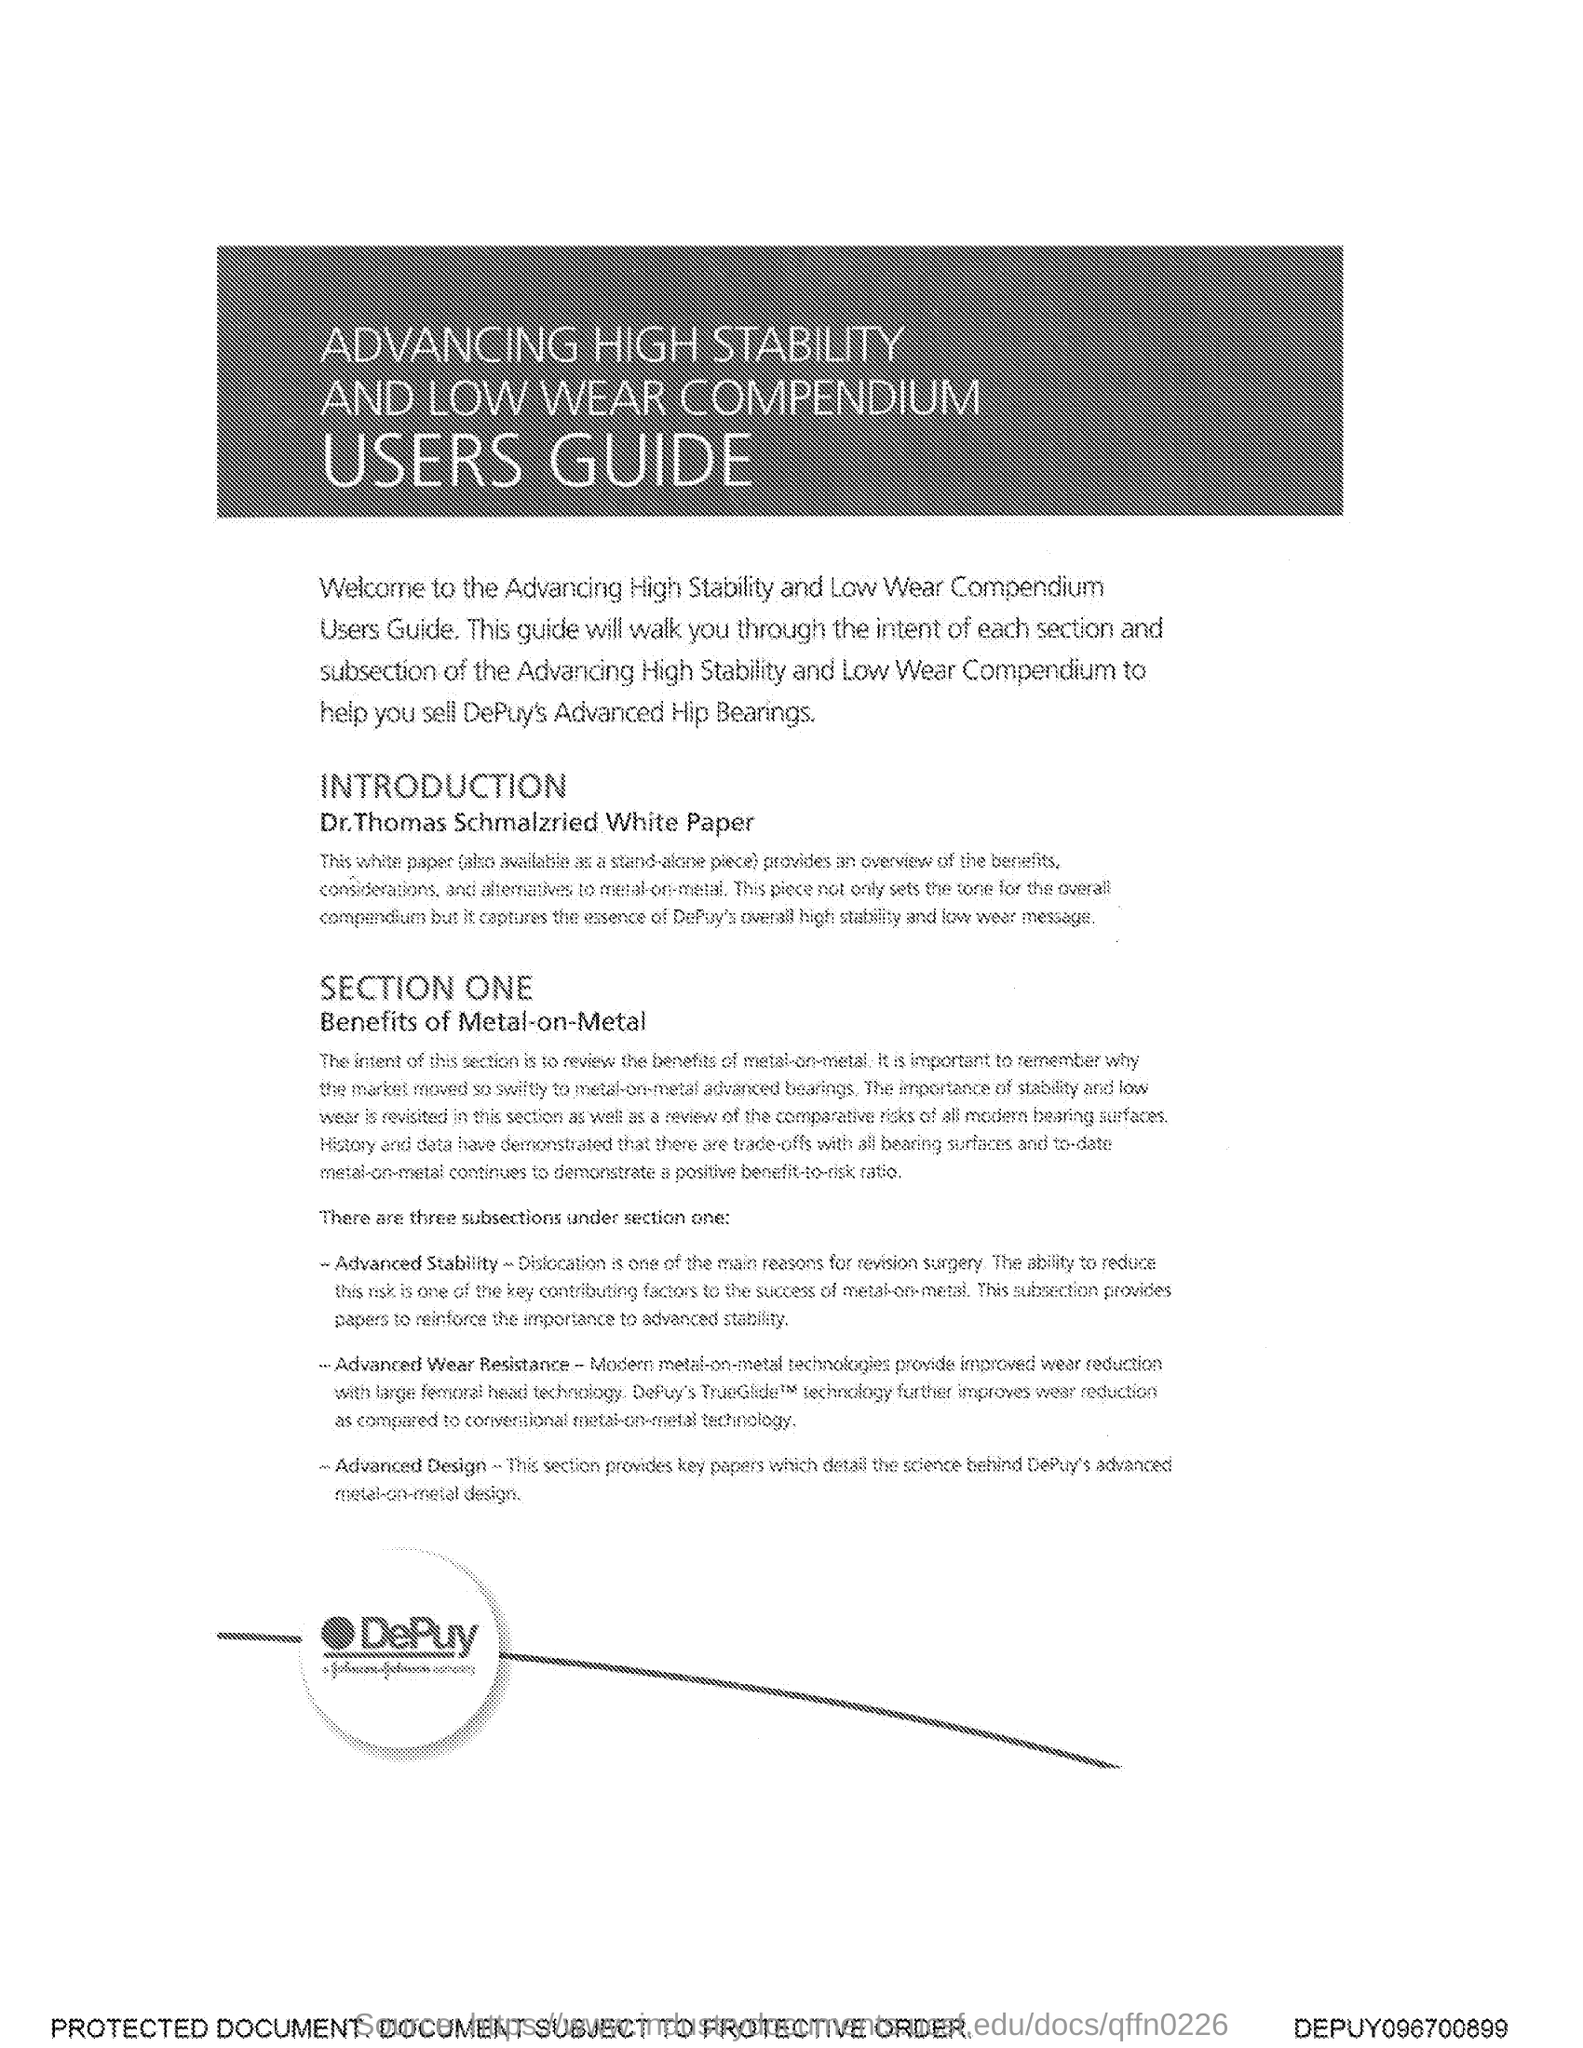Mention a couple of crucial points in this snapshot. The document is titled "Advancing High Stability and Low Wear Compendium Users Guide. 